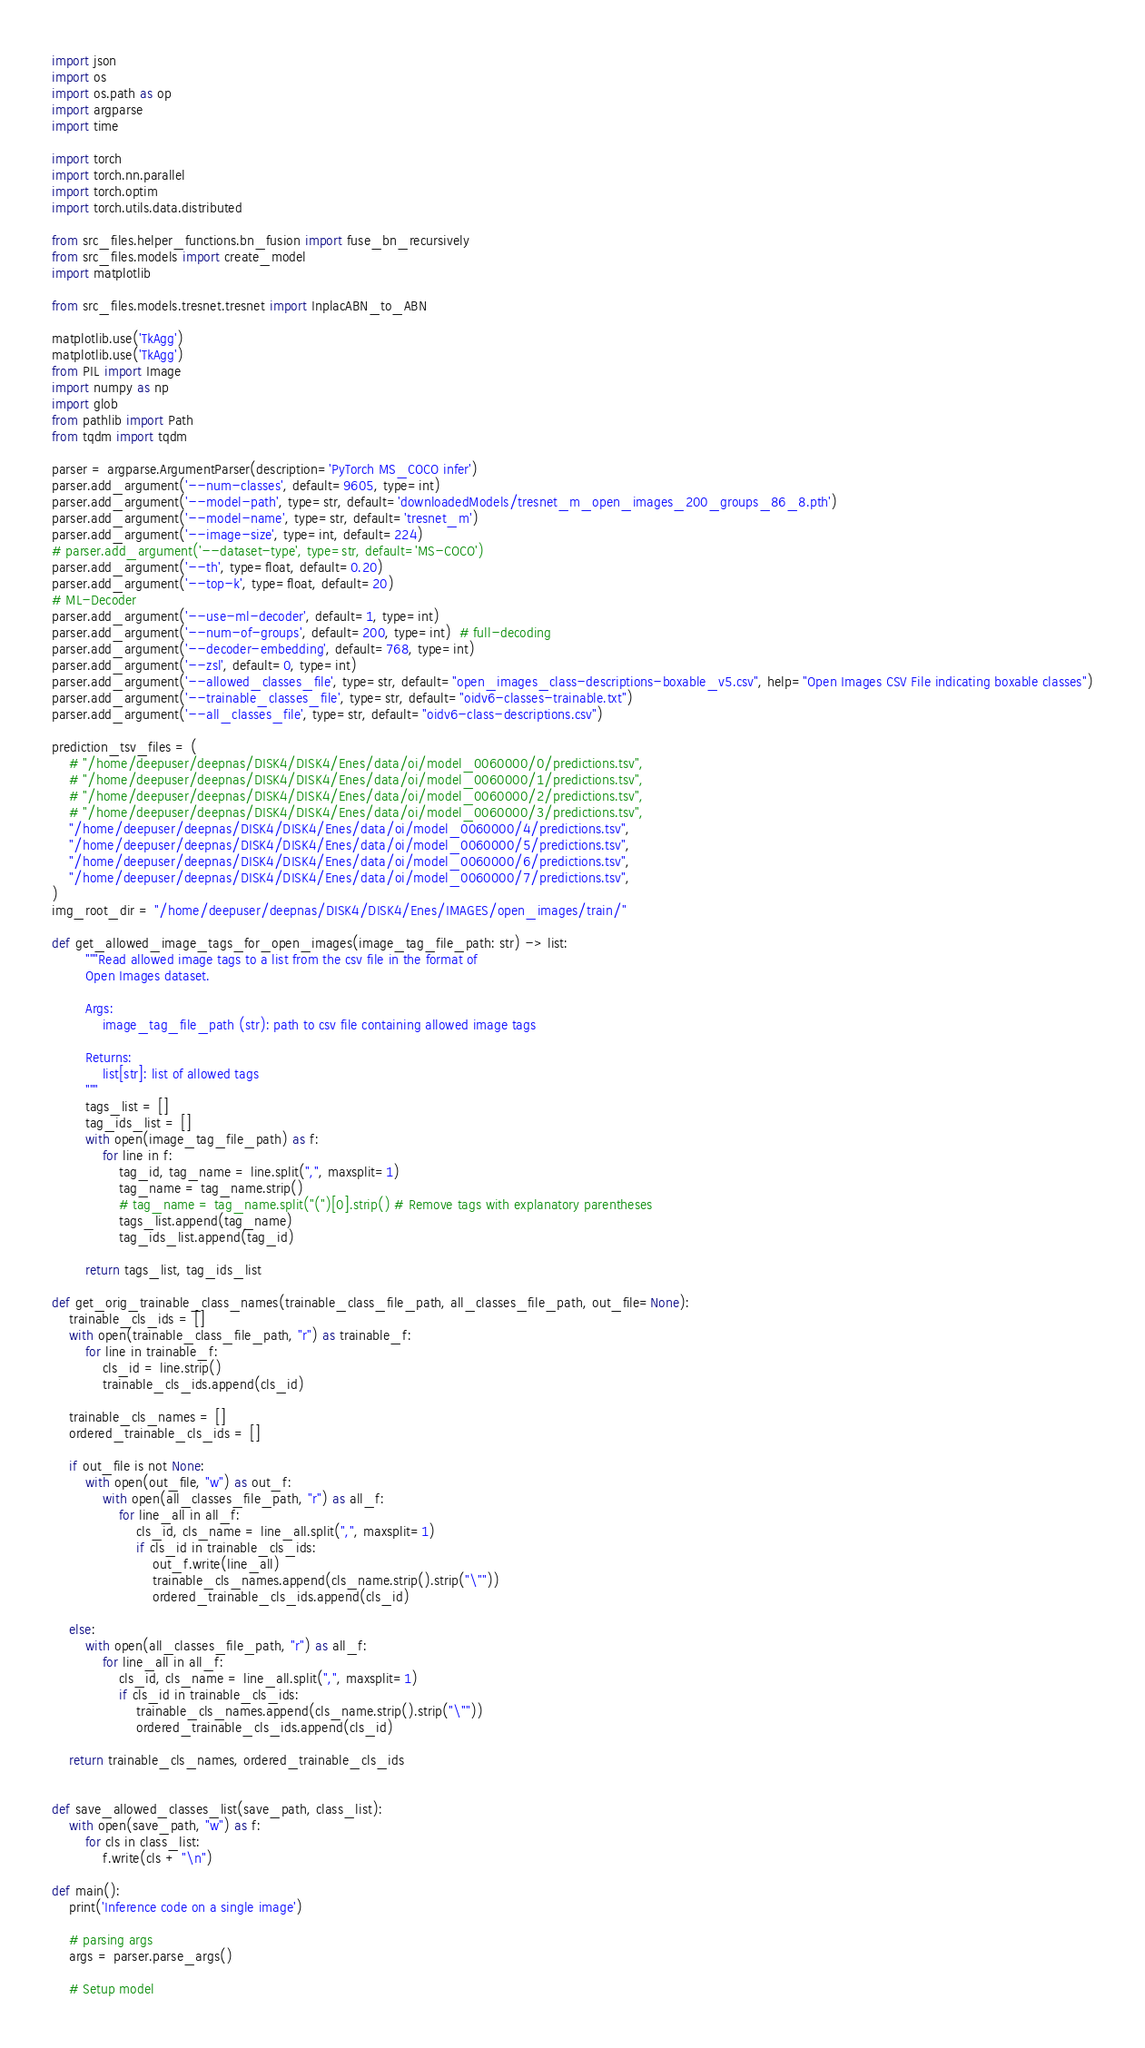<code> <loc_0><loc_0><loc_500><loc_500><_Python_>import json
import os
import os.path as op
import argparse
import time

import torch
import torch.nn.parallel
import torch.optim
import torch.utils.data.distributed

from src_files.helper_functions.bn_fusion import fuse_bn_recursively
from src_files.models import create_model
import matplotlib

from src_files.models.tresnet.tresnet import InplacABN_to_ABN

matplotlib.use('TkAgg')
matplotlib.use('TkAgg')
from PIL import Image
import numpy as np
import glob
from pathlib import Path
from tqdm import tqdm

parser = argparse.ArgumentParser(description='PyTorch MS_COCO infer')
parser.add_argument('--num-classes', default=9605, type=int)
parser.add_argument('--model-path', type=str, default='downloadedModels/tresnet_m_open_images_200_groups_86_8.pth')
parser.add_argument('--model-name', type=str, default='tresnet_m')
parser.add_argument('--image-size', type=int, default=224)
# parser.add_argument('--dataset-type', type=str, default='MS-COCO')
parser.add_argument('--th', type=float, default=0.20)
parser.add_argument('--top-k', type=float, default=20)
# ML-Decoder
parser.add_argument('--use-ml-decoder', default=1, type=int)
parser.add_argument('--num-of-groups', default=200, type=int)  # full-decoding
parser.add_argument('--decoder-embedding', default=768, type=int)
parser.add_argument('--zsl', default=0, type=int)
parser.add_argument('--allowed_classes_file', type=str, default="open_images_class-descriptions-boxable_v5.csv", help="Open Images CSV File indicating boxable classes")
parser.add_argument('--trainable_classes_file', type=str, default="oidv6-classes-trainable.txt")
parser.add_argument('--all_classes_file', type=str, default="oidv6-class-descriptions.csv")

prediction_tsv_files = (
    # "/home/deepuser/deepnas/DISK4/DISK4/Enes/data/oi/model_0060000/0/predictions.tsv",
    # "/home/deepuser/deepnas/DISK4/DISK4/Enes/data/oi/model_0060000/1/predictions.tsv",
    # "/home/deepuser/deepnas/DISK4/DISK4/Enes/data/oi/model_0060000/2/predictions.tsv",
    # "/home/deepuser/deepnas/DISK4/DISK4/Enes/data/oi/model_0060000/3/predictions.tsv",
    "/home/deepuser/deepnas/DISK4/DISK4/Enes/data/oi/model_0060000/4/predictions.tsv",
    "/home/deepuser/deepnas/DISK4/DISK4/Enes/data/oi/model_0060000/5/predictions.tsv",
    "/home/deepuser/deepnas/DISK4/DISK4/Enes/data/oi/model_0060000/6/predictions.tsv",
    "/home/deepuser/deepnas/DISK4/DISK4/Enes/data/oi/model_0060000/7/predictions.tsv",
)
img_root_dir = "/home/deepuser/deepnas/DISK4/DISK4/Enes/IMAGES/open_images/train/"

def get_allowed_image_tags_for_open_images(image_tag_file_path: str) -> list:
        """Read allowed image tags to a list from the csv file in the format of
        Open Images dataset.

        Args:
            image_tag_file_path (str): path to csv file containing allowed image tags

        Returns:
            list[str]: list of allowed tags
        """
        tags_list = []
        tag_ids_list = []
        with open(image_tag_file_path) as f:
            for line in f:
                tag_id, tag_name = line.split(",", maxsplit=1)
                tag_name = tag_name.strip()
                # tag_name = tag_name.split("(")[0].strip() # Remove tags with explanatory parentheses
                tags_list.append(tag_name)
                tag_ids_list.append(tag_id)

        return tags_list, tag_ids_list

def get_orig_trainable_class_names(trainable_class_file_path, all_classes_file_path, out_file=None):
    trainable_cls_ids = []
    with open(trainable_class_file_path, "r") as trainable_f:
        for line in trainable_f:
            cls_id = line.strip()
            trainable_cls_ids.append(cls_id)

    trainable_cls_names = []
    ordered_trainable_cls_ids = []
    
    if out_file is not None:
        with open(out_file, "w") as out_f:
            with open(all_classes_file_path, "r") as all_f:
                for line_all in all_f:
                    cls_id, cls_name = line_all.split(",", maxsplit=1)
                    if cls_id in trainable_cls_ids:
                        out_f.write(line_all)
                        trainable_cls_names.append(cls_name.strip().strip("\""))
                        ordered_trainable_cls_ids.append(cls_id)

    else:
        with open(all_classes_file_path, "r") as all_f:
            for line_all in all_f:
                cls_id, cls_name = line_all.split(",", maxsplit=1)
                if cls_id in trainable_cls_ids:
                    trainable_cls_names.append(cls_name.strip().strip("\""))
                    ordered_trainable_cls_ids.append(cls_id)

    return trainable_cls_names, ordered_trainable_cls_ids

    
def save_allowed_classes_list(save_path, class_list):
    with open(save_path, "w") as f:
        for cls in class_list:
            f.write(cls + "\n")

def main():
    print('Inference code on a single image')

    # parsing args
    args = parser.parse_args()

    # Setup model</code> 